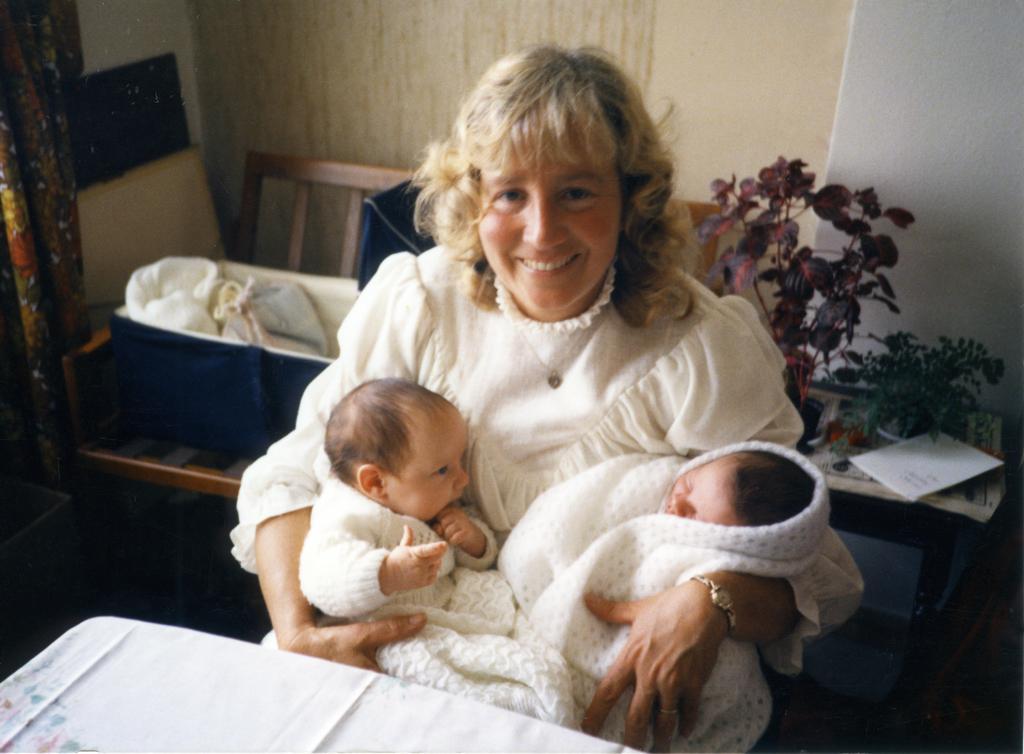Please provide a concise description of this image. This image is taken indoors. At the bottom of the image there is a table with a tablecloth. In the middle of the image a woman is sitting on the chair and she is holding two babies in her hands. They are covered with a scarf. In the background there is a wall and a curtain. There is an empty chair and a table with a flower vase on it. 